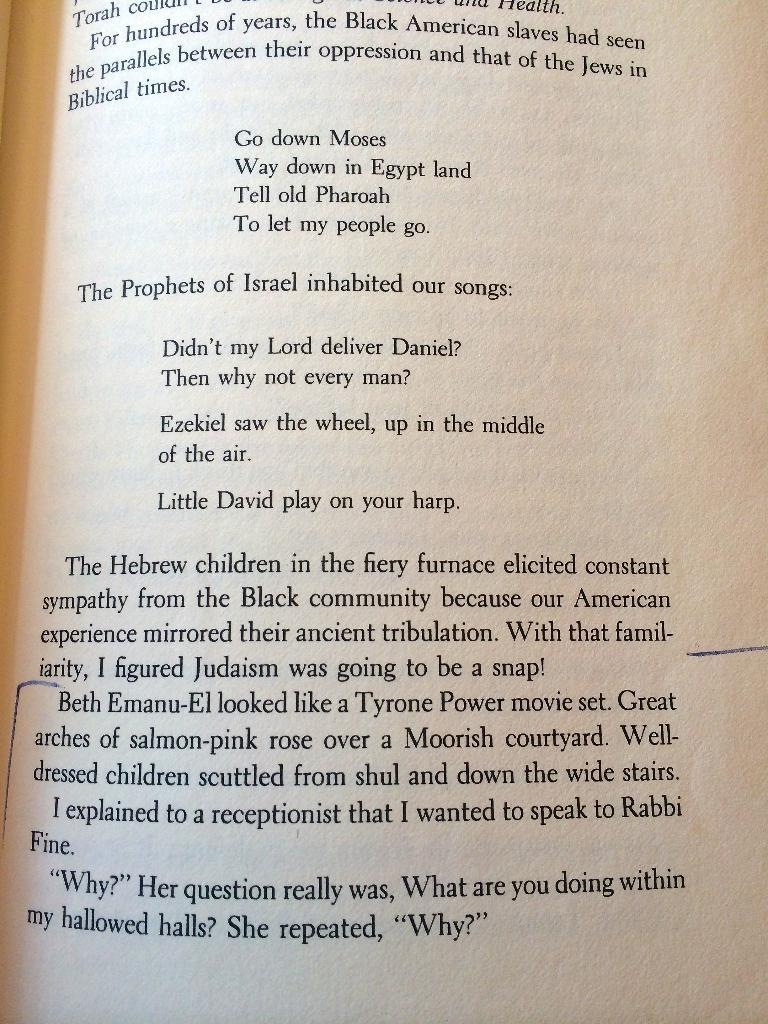<image>
Give a short and clear explanation of the subsequent image. Chapter book that have information about Israel and black american slaves 